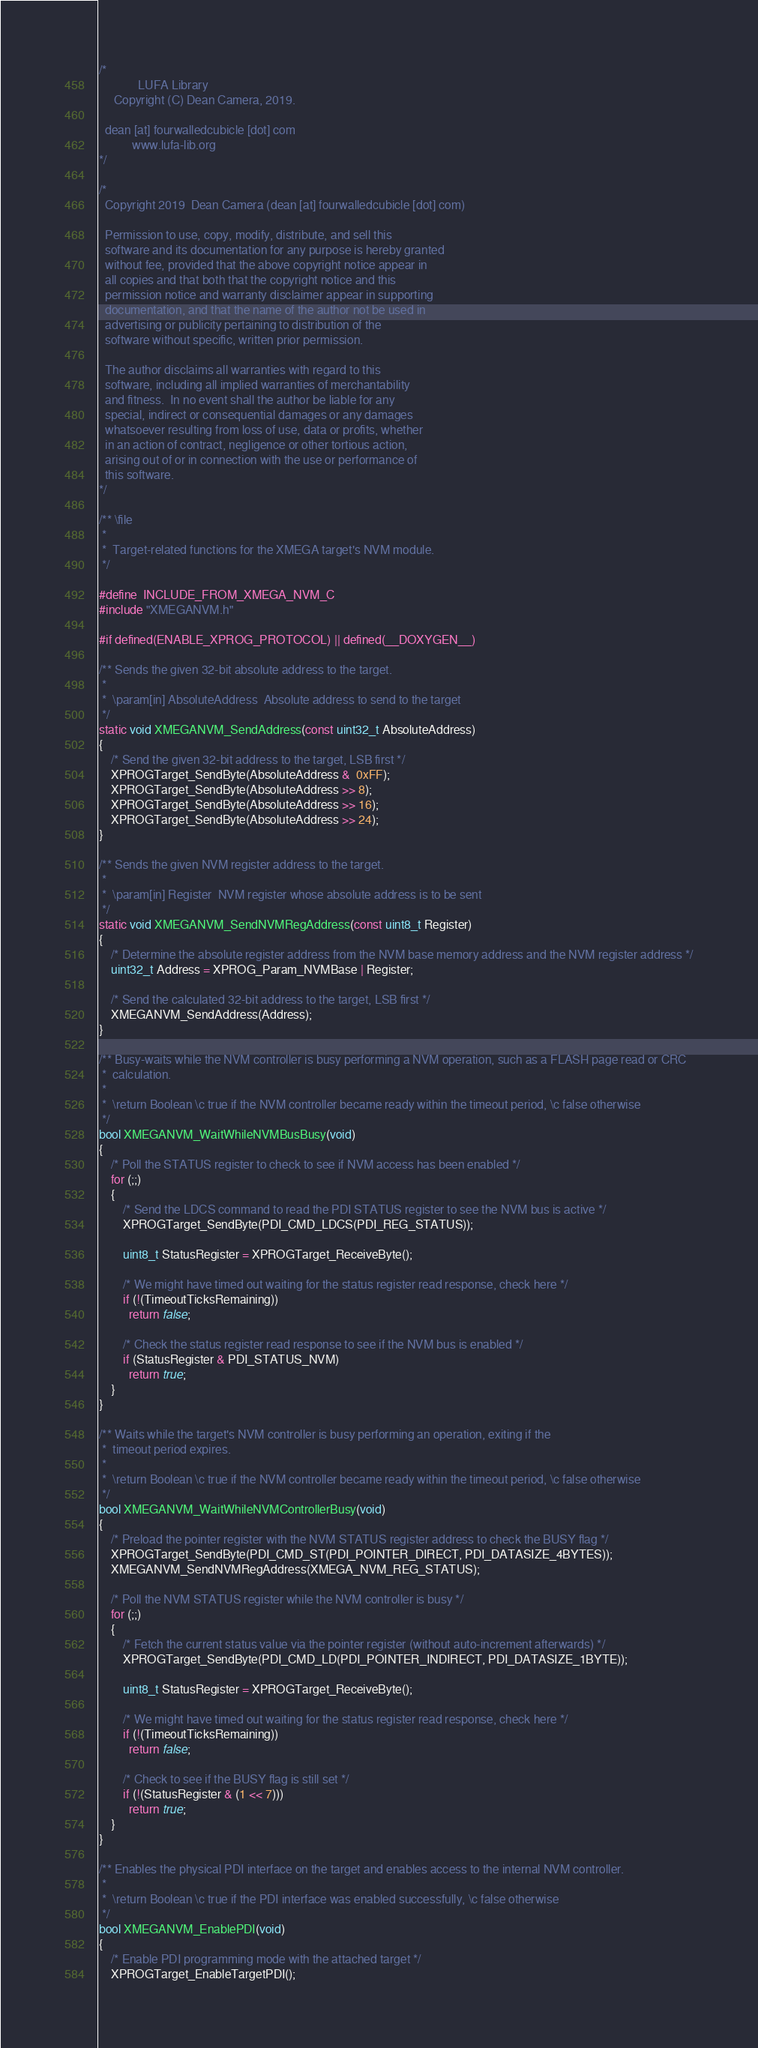<code> <loc_0><loc_0><loc_500><loc_500><_C_>/*
             LUFA Library
     Copyright (C) Dean Camera, 2019.

  dean [at] fourwalledcubicle [dot] com
           www.lufa-lib.org
*/

/*
  Copyright 2019  Dean Camera (dean [at] fourwalledcubicle [dot] com)

  Permission to use, copy, modify, distribute, and sell this
  software and its documentation for any purpose is hereby granted
  without fee, provided that the above copyright notice appear in
  all copies and that both that the copyright notice and this
  permission notice and warranty disclaimer appear in supporting
  documentation, and that the name of the author not be used in
  advertising or publicity pertaining to distribution of the
  software without specific, written prior permission.

  The author disclaims all warranties with regard to this
  software, including all implied warranties of merchantability
  and fitness.  In no event shall the author be liable for any
  special, indirect or consequential damages or any damages
  whatsoever resulting from loss of use, data or profits, whether
  in an action of contract, negligence or other tortious action,
  arising out of or in connection with the use or performance of
  this software.
*/

/** \file
 *
 *  Target-related functions for the XMEGA target's NVM module.
 */

#define  INCLUDE_FROM_XMEGA_NVM_C
#include "XMEGANVM.h"

#if defined(ENABLE_XPROG_PROTOCOL) || defined(__DOXYGEN__)

/** Sends the given 32-bit absolute address to the target.
 *
 *  \param[in] AbsoluteAddress  Absolute address to send to the target
 */
static void XMEGANVM_SendAddress(const uint32_t AbsoluteAddress)
{
	/* Send the given 32-bit address to the target, LSB first */
	XPROGTarget_SendByte(AbsoluteAddress &  0xFF);
	XPROGTarget_SendByte(AbsoluteAddress >> 8);
	XPROGTarget_SendByte(AbsoluteAddress >> 16);
	XPROGTarget_SendByte(AbsoluteAddress >> 24);
}

/** Sends the given NVM register address to the target.
 *
 *  \param[in] Register  NVM register whose absolute address is to be sent
 */
static void XMEGANVM_SendNVMRegAddress(const uint8_t Register)
{
	/* Determine the absolute register address from the NVM base memory address and the NVM register address */
	uint32_t Address = XPROG_Param_NVMBase | Register;

	/* Send the calculated 32-bit address to the target, LSB first */
	XMEGANVM_SendAddress(Address);
}

/** Busy-waits while the NVM controller is busy performing a NVM operation, such as a FLASH page read or CRC
 *  calculation.
 *
 *  \return Boolean \c true if the NVM controller became ready within the timeout period, \c false otherwise
 */
bool XMEGANVM_WaitWhileNVMBusBusy(void)
{
	/* Poll the STATUS register to check to see if NVM access has been enabled */
	for (;;)
	{
		/* Send the LDCS command to read the PDI STATUS register to see the NVM bus is active */
		XPROGTarget_SendByte(PDI_CMD_LDCS(PDI_REG_STATUS));

		uint8_t StatusRegister = XPROGTarget_ReceiveByte();

		/* We might have timed out waiting for the status register read response, check here */
		if (!(TimeoutTicksRemaining))
		  return false;

		/* Check the status register read response to see if the NVM bus is enabled */
		if (StatusRegister & PDI_STATUS_NVM)
		  return true;
	}
}

/** Waits while the target's NVM controller is busy performing an operation, exiting if the
 *  timeout period expires.
 *
 *  \return Boolean \c true if the NVM controller became ready within the timeout period, \c false otherwise
 */
bool XMEGANVM_WaitWhileNVMControllerBusy(void)
{
	/* Preload the pointer register with the NVM STATUS register address to check the BUSY flag */
	XPROGTarget_SendByte(PDI_CMD_ST(PDI_POINTER_DIRECT, PDI_DATASIZE_4BYTES));
	XMEGANVM_SendNVMRegAddress(XMEGA_NVM_REG_STATUS);

	/* Poll the NVM STATUS register while the NVM controller is busy */
	for (;;)
	{
		/* Fetch the current status value via the pointer register (without auto-increment afterwards) */
		XPROGTarget_SendByte(PDI_CMD_LD(PDI_POINTER_INDIRECT, PDI_DATASIZE_1BYTE));

		uint8_t StatusRegister = XPROGTarget_ReceiveByte();

		/* We might have timed out waiting for the status register read response, check here */
		if (!(TimeoutTicksRemaining))
		  return false;

		/* Check to see if the BUSY flag is still set */
		if (!(StatusRegister & (1 << 7)))
		  return true;
	}
}

/** Enables the physical PDI interface on the target and enables access to the internal NVM controller.
 *
 *  \return Boolean \c true if the PDI interface was enabled successfully, \c false otherwise
 */
bool XMEGANVM_EnablePDI(void)
{
	/* Enable PDI programming mode with the attached target */
	XPROGTarget_EnableTargetPDI();
</code> 